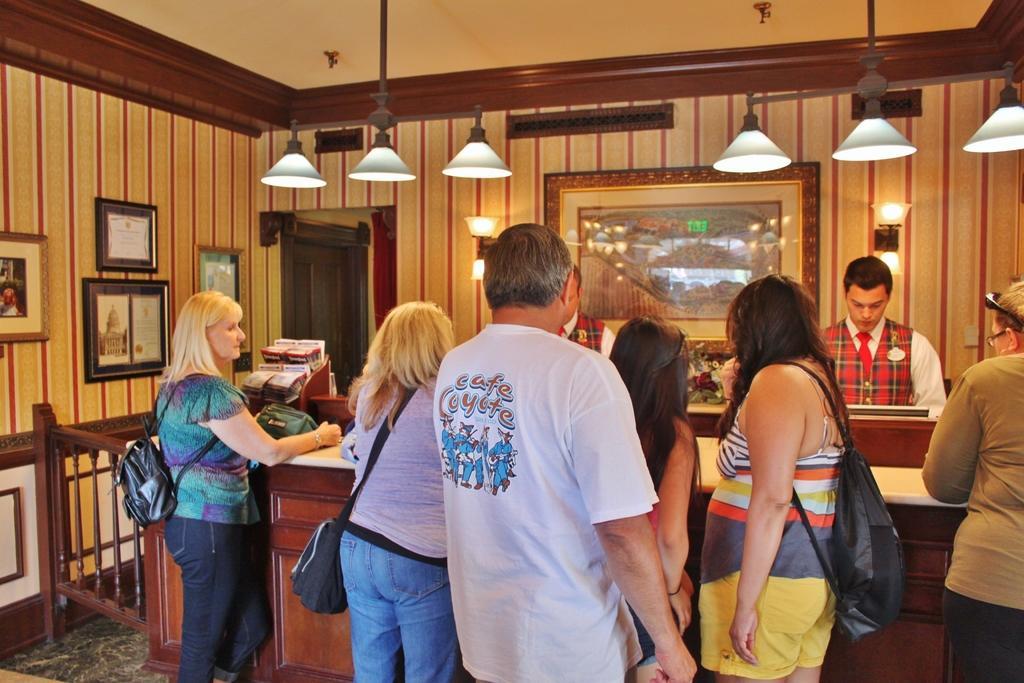In one or two sentences, can you explain what this image depicts? In this picture I can see few people standing, few photo frames on the walls and few lights. I can see a monitor and few papers in the stand. I can see few women wearing bags and the picture looks like a reception. 